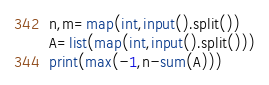Convert code to text. <code><loc_0><loc_0><loc_500><loc_500><_Python_>n,m=map(int,input().split())
A=list(map(int,input().split()))
print(max(-1,n-sum(A)))</code> 